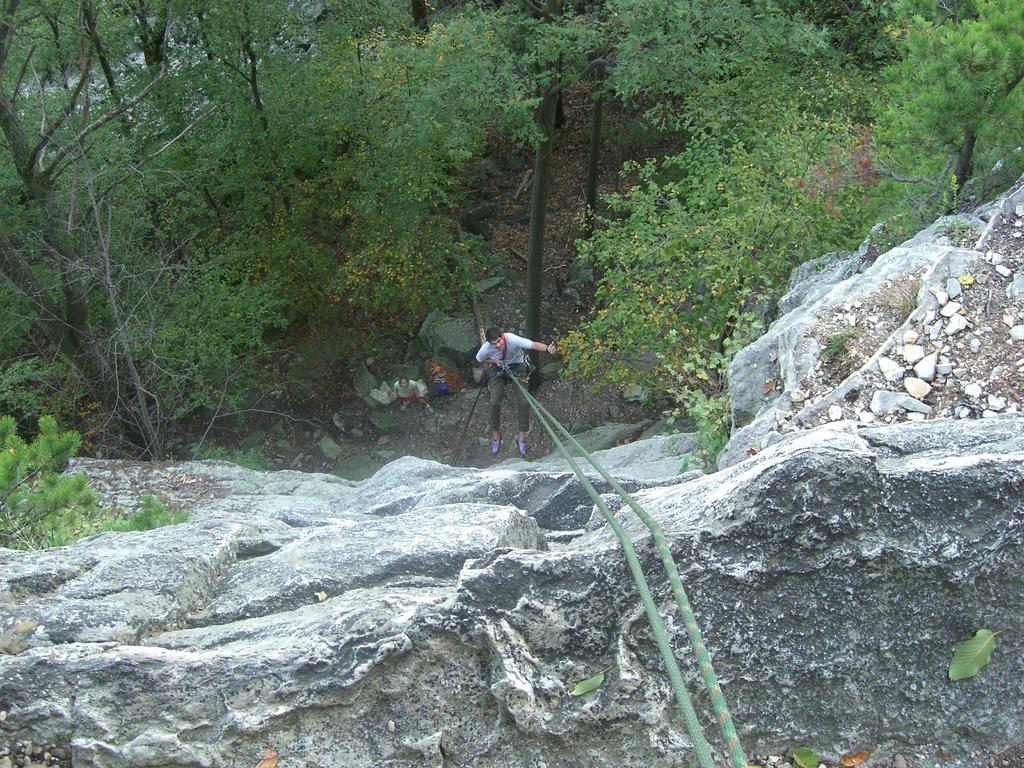What is the main subject in the center of the image? There is a boy in the center of the image. What is the boy doing in the image? The boy is hanging from a rope. What can be seen in the background of the image? There are trees at the top side of the image. Can you see a snake slithering near the boy in the image? There is no snake present in the image. What type of cup is the boy holding while hanging from the rope? The boy is not holding a cup in the image. 